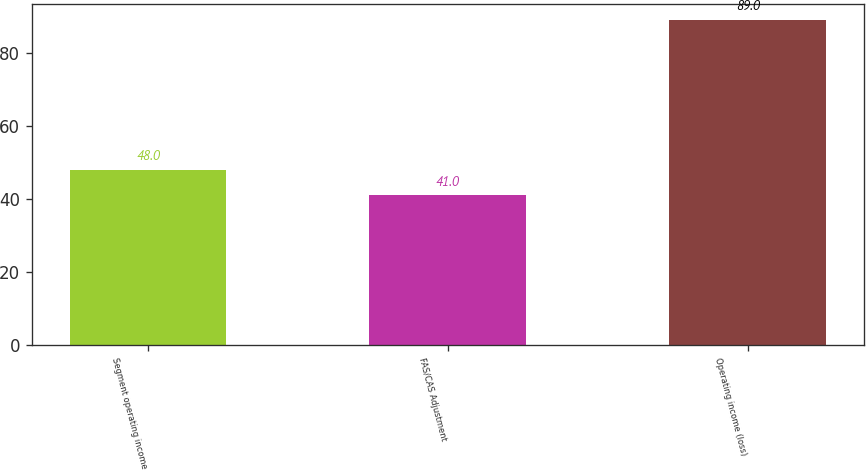Convert chart. <chart><loc_0><loc_0><loc_500><loc_500><bar_chart><fcel>Segment operating income<fcel>FAS/CAS Adjustment<fcel>Operating income (loss)<nl><fcel>48<fcel>41<fcel>89<nl></chart> 